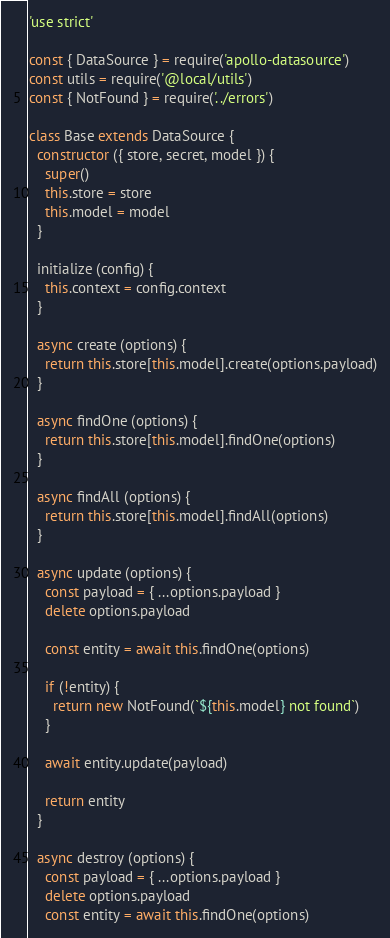<code> <loc_0><loc_0><loc_500><loc_500><_JavaScript_>'use strict'

const { DataSource } = require('apollo-datasource')
const utils = require('@local/utils')
const { NotFound } = require('../errors')

class Base extends DataSource {
  constructor ({ store, secret, model }) {
    super()
    this.store = store
    this.model = model
  }

  initialize (config) {
    this.context = config.context
  }

  async create (options) {
    return this.store[this.model].create(options.payload)
  }

  async findOne (options) {
    return this.store[this.model].findOne(options)
  }

  async findAll (options) {
    return this.store[this.model].findAll(options)
  }

  async update (options) {
    const payload = { ...options.payload }
    delete options.payload

    const entity = await this.findOne(options)

    if (!entity) {
      return new NotFound(`${this.model} not found`)
    }

    await entity.update(payload)

    return entity
  }
  
  async destroy (options) {
    const payload = { ...options.payload }
    delete options.payload
    const entity = await this.findOne(options)
</code> 